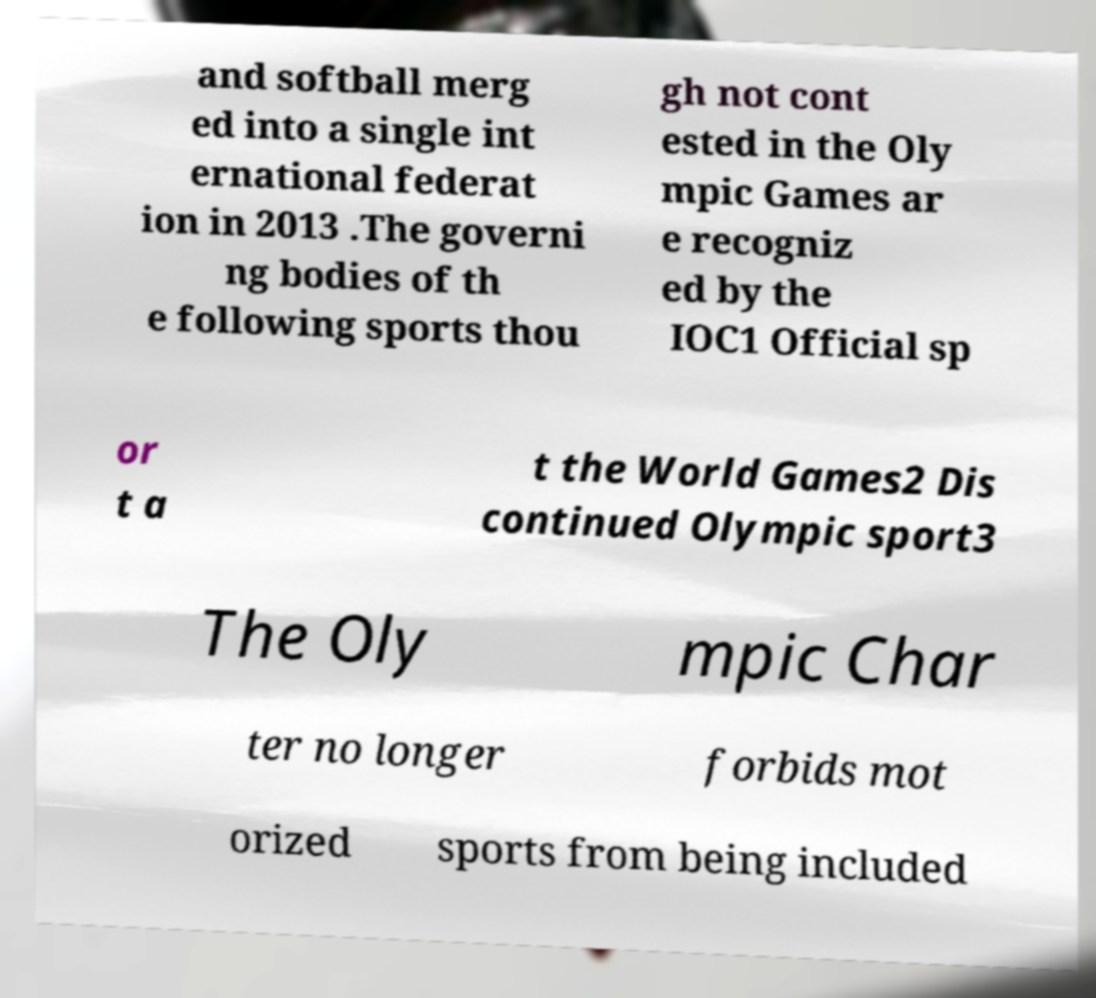I need the written content from this picture converted into text. Can you do that? and softball merg ed into a single int ernational federat ion in 2013 .The governi ng bodies of th e following sports thou gh not cont ested in the Oly mpic Games ar e recogniz ed by the IOC1 Official sp or t a t the World Games2 Dis continued Olympic sport3 The Oly mpic Char ter no longer forbids mot orized sports from being included 